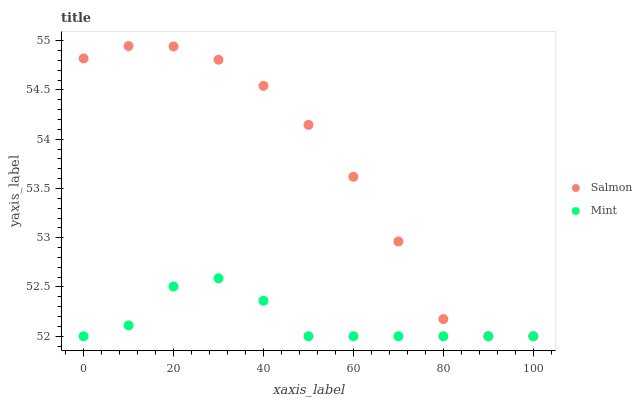Does Mint have the minimum area under the curve?
Answer yes or no. Yes. Does Salmon have the maximum area under the curve?
Answer yes or no. Yes. Does Salmon have the minimum area under the curve?
Answer yes or no. No. Is Mint the smoothest?
Answer yes or no. Yes. Is Salmon the roughest?
Answer yes or no. Yes. Is Salmon the smoothest?
Answer yes or no. No. Does Mint have the lowest value?
Answer yes or no. Yes. Does Salmon have the highest value?
Answer yes or no. Yes. Does Mint intersect Salmon?
Answer yes or no. Yes. Is Mint less than Salmon?
Answer yes or no. No. Is Mint greater than Salmon?
Answer yes or no. No. 